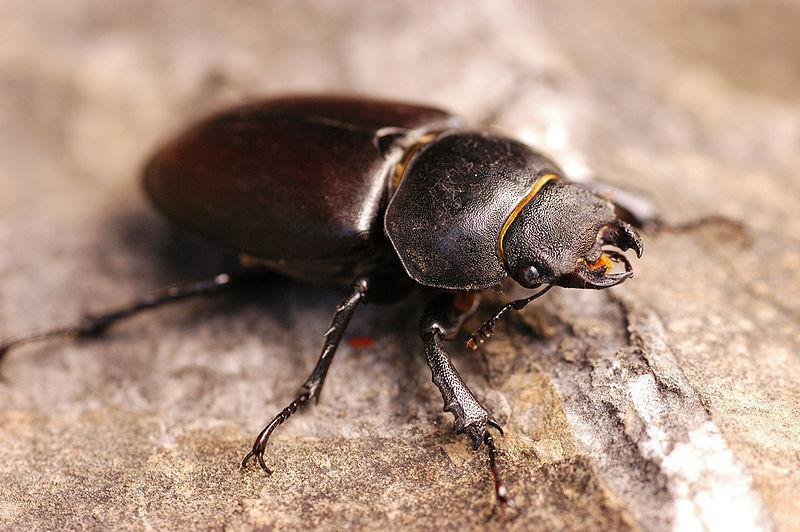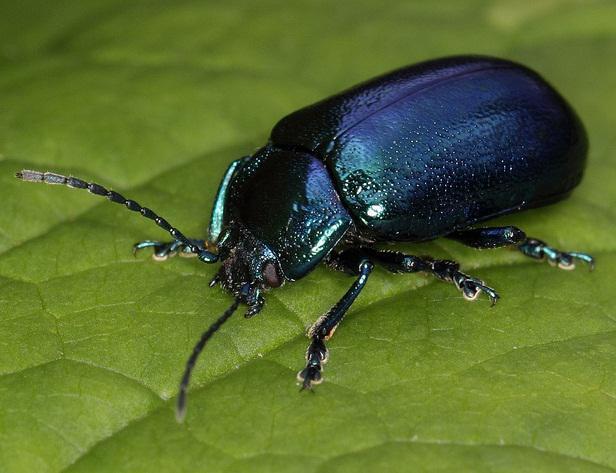The first image is the image on the left, the second image is the image on the right. Given the left and right images, does the statement "The insect in one of the images is standing upon a green leaf." hold true? Answer yes or no. Yes. 